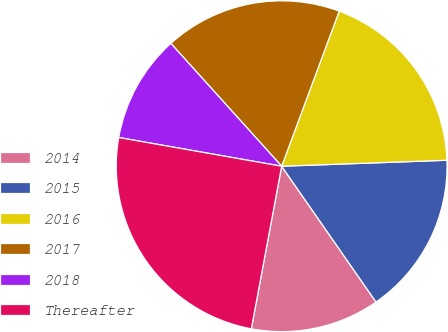Convert chart. <chart><loc_0><loc_0><loc_500><loc_500><pie_chart><fcel>2014<fcel>2015<fcel>2016<fcel>2017<fcel>2018<fcel>Thereafter<nl><fcel>12.6%<fcel>15.91%<fcel>18.77%<fcel>17.34%<fcel>10.54%<fcel>24.84%<nl></chart> 